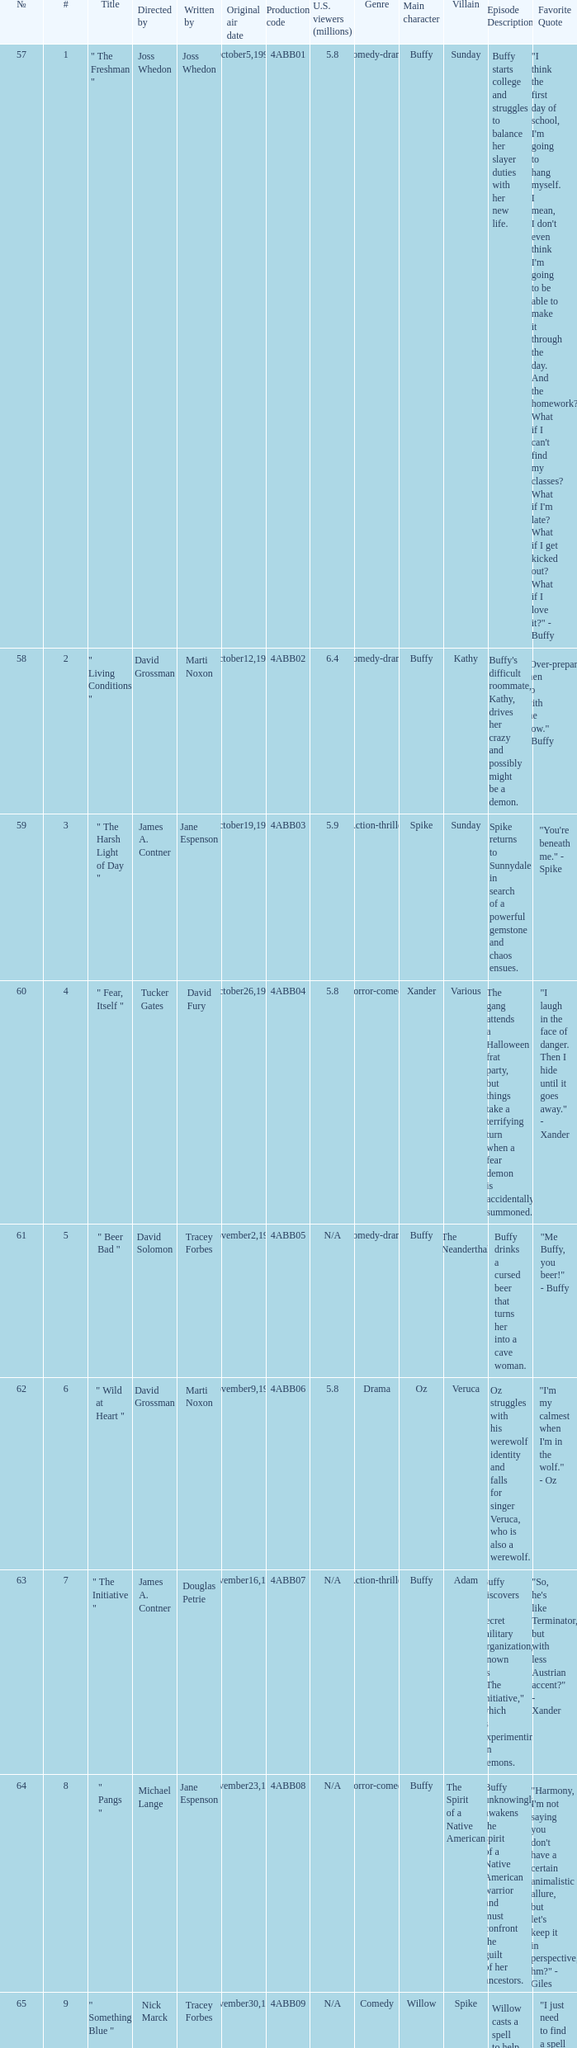What is the production code for the episode with 5.5 million u.s. viewers? 4ABB16. Could you parse the entire table? {'header': ['№', '#', 'Title', 'Directed by', 'Written by', 'Original air date', 'Production code', 'U.S. viewers (millions)', 'Genre', 'Main character', 'Villain', 'Episode Description', 'Favorite Quote'], 'rows': [['57', '1', '" The Freshman "', 'Joss Whedon', 'Joss Whedon', 'October5,1999', '4ABB01', '5.8', 'Comedy-drama', 'Buffy', 'Sunday', 'Buffy starts college and struggles to balance her slayer duties with her new life.', '"I think the first day of school, I\'m going to hang myself. I mean, I don\'t even think I\'m going to be able to make it through the day. And the homework? What if I can\'t find my classes? What if I\'m late? What if I get kicked out? What if I love it?" - Buffy'], ['58', '2', '" Living Conditions "', 'David Grossman', 'Marti Noxon', 'October12,1999', '4ABB02', '6.4', 'Comedy-drama', 'Buffy', 'Kathy', "Buffy's difficult roommate, Kathy, drives her crazy and possibly might be a demon.", '"Over-prepare, then go with the flow." - Buffy'], ['59', '3', '" The Harsh Light of Day "', 'James A. Contner', 'Jane Espenson', 'October19,1999', '4ABB03', '5.9', 'Action-thriller', 'Spike', 'Sunday', 'Spike returns to Sunnydale in search of a powerful gemstone and chaos ensues.', '"You\'re beneath me." - Spike'], ['60', '4', '" Fear, Itself "', 'Tucker Gates', 'David Fury', 'October26,1999', '4ABB04', '5.8', 'Horror-comedy', 'Xander', 'Various', 'The gang attends a Halloween frat party, but things take a terrifying turn when a fear demon is accidentally summoned.', '"I laugh in the face of danger. Then I hide until it goes away." - Xander'], ['61', '5', '" Beer Bad "', 'David Solomon', 'Tracey Forbes', 'November2,1999', '4ABB05', 'N/A', 'Comedy-drama', 'Buffy', 'The Neanderthal', 'Buffy drinks a cursed beer that turns her into a cave woman.', '"Me Buffy, you beer!" - Buffy'], ['62', '6', '" Wild at Heart "', 'David Grossman', 'Marti Noxon', 'November9,1999', '4ABB06', '5.8', 'Drama', 'Oz', 'Veruca', 'Oz struggles with his werewolf identity and falls for singer Veruca, who is also a werewolf.', '"I\'m my calmest when I\'m in the wolf." - Oz'], ['63', '7', '" The Initiative "', 'James A. Contner', 'Douglas Petrie', 'November16,1999', '4ABB07', 'N/A', 'Action-thriller', 'Buffy', 'Adam', 'Buffy discovers a secret military organization, known as "The Initiative," which is experimenting on demons.', '"So, he\'s like Terminator, but with less Austrian accent?" - Xander'], ['64', '8', '" Pangs "', 'Michael Lange', 'Jane Espenson', 'November23,1999', '4ABB08', 'N/A', 'Horror-comedy', 'Buffy', 'The Spirit of a Native American', 'Buffy unknowingly awakens the spirit of a Native American warrior and must confront the guilt of her ancestors.', '"Harmony, I\'m not saying you don\'t have a certain animalistic allure, but let\'s keep it in perspective, hm?" - Giles'], ['65', '9', '" Something Blue "', 'Nick Marck', 'Tracey Forbes', 'November30,1999', '4ABB09', 'N/A', 'Comedy', 'Willow', 'Spike', 'Willow casts a spell to help get over her breakup with Oz, but it backfires and causes Spike and Buffy to fall in love.', '"I just need to find a spell to make me stop using so many spells." - Willow'], ['66', '10', '" Hush "', 'Joss Whedon', 'Joss Whedon', 'December14,1999', '4ABB10', '5.9', 'Horror', 'Buffy', 'The Gentlemen', 'The town of Sunnydale is struck by a group of mysterious, silent monsters known as The Gentlemen, who steal the voices of the inhabitants.', '"Can\'t even shout, can\'t even cry. The Gentlemen are coming by." - The Gentlemen'], ['67', '11', '" Doomed "', 'James A. Contner', 'Marti Noxon & David Fury & Jane Espenson', 'January18,2000', '4ABB11', 'N/A', 'Action-thriller', 'Buffy', 'The Hellions', 'Buffy and the gang try to stop an apocalypse caused by the demon, Lagos, and face off against The Hellions, a rival gang of demons.', '"I laugh in the face of danger, then I hide until it goes away - and sometimes I run away, let\'s not forget that part." - Xander'], ['68', '12', '" A New Man "', 'Michael Gershman', 'Jane Espenson', 'January25,2000', '4ABB12', 'N/A', 'Comedy-drama', 'Giles', 'Ethan Rayne', 'Giles is transformed into a demon by Ethan Rayne and struggles to convince his friends of his true identity.', '"I have to find him. He\'s got quite a knack for getting himself killed." - Giles'], ['69', '13', '" The I in Team "', 'James A. Contner', 'David Fury', 'February8,2000', '4ABB13', 'N/A', 'Action-thriller', 'Buffy', 'Maggie Walsh', 'Buffy joins The Initiative to learn more about their activities, but discovers they have plans to eliminate all demons, including her vampire friend, Spike.', '"Hostile 17, need I remind you that the mission of this facility is to capture, control and study the demon population, not let them loose on college girls?" - Maggie Walsh'], ['70', '14', '" Goodbye Iowa "', 'David Solomon', 'Marti Noxon', 'February15,2000', '4ABB14', 'N/A', 'Drama', 'Buffy', 'Riley Finn', 'Buffy and Riley discover the truth about The Initiative and must save the town from Adam, a hybrid demon experiment.', '"I\'m not saying we could beat them in a fight, but you\'re worthless if you\'re not even a diversion." - Buffy'], ['71', '15', '" This Year\'s Girl " (Part 1)', 'Michael Gershman', 'Douglas Petrie', 'February22,2000', '4ABB15', 'N/A', 'Action-thriller', 'Buffy', 'Faith', 'Faith awakens from her coma and teams up with a demon to seek revenge on Buffy.', '"You\'re one step away from the big house, girlfriend. And I\'m not talking Martha Stewart." - Faith'], ['72', '16', '" Who Are You " (Part 2)', 'Joss Whedon', 'Joss Whedon', 'February29,2000', '4ABB16', '5.5', 'Action-thriller', 'Buffy/Faith', 'Mayor Wilkins/Faith', 'Buffy and Faith switch bodies due to a spell and Faith impersonates Buffy while causing chaos in her personal life.', '"I\'m the original one-eyed chicklet in the kingdom of the blind." - Buffy/Faith'], ['73', '17', '" Superstar "', 'David Grossman', 'Jane Espenson', 'April4,2000', '4ABB17', 'N/A', 'Comedy-drama', 'Jonathan', 'None', 'A spell causes everyone to believe that Jonathan is the hero of Sunnydale, but his excessive ego begins to cause problems.', '"In my world, you were never even a sidekick." - Jonathan'], ['74', '18', '" Where the Wild Things Are "', 'David Solomon', 'Tracey Forbes', 'April25,2000', '4ABB18', 'N/A', 'Horror', 'Buffy', 'James & Elizabeth', 'Buffy and Riley become trapped in a haunted house with two ghosts who are stuck in a never-ending cycle of passion.', '"Well, how about \'I\'m gonna take in a lot of sugar, and I\'m gonna get on a really big scary elevator and I\'m gonna free-fall for four weeks.\' Does that work?" - Xander'], ['75', '19', '" New Moon Rising "', 'James A. Contner', 'Marti Noxon', 'May2,2000', '4ABB19', '4.6', 'Drama', 'Oz', 'Veruca', 'Oz returns to Sunnydale and must deal with his remaining feelings for Willow and his new relationship with Veruca.', '"I learned a couple of things when I was away... like how to control the wolf, and... drive stick shift." - Oz'], ['76', '20', '" The Yoko Factor " (Part 1)', 'David Grossman', 'Douglas Petrie', 'May9,2000', '4ABB20', '4.9', 'Drama', 'Xander', 'Adam', 'Tensions rise between Buffy and her friends as Adam manipulates and breaks up their relationships.', '"Oh, you mean the kind of things that could tear friends apart, create mistrust, and ultimately bring about the downfall of society. You need a bigger basement." - Willow'], ['77', '21', '" Primeval " (Part 2)', 'James A. Contner', 'David Fury', 'May16,2000', '4ABB21', '5.2', 'Action-thriller', 'Buffy', 'Adam', 'Buffy and her friends join forces and combine their strengths to take down Adam once and for all.', '"So, let me get this straight. We\'re helping the Initiative to be big, bad, and terrible, because why? You think they can wipe out every vampire?" - Xander']]} 